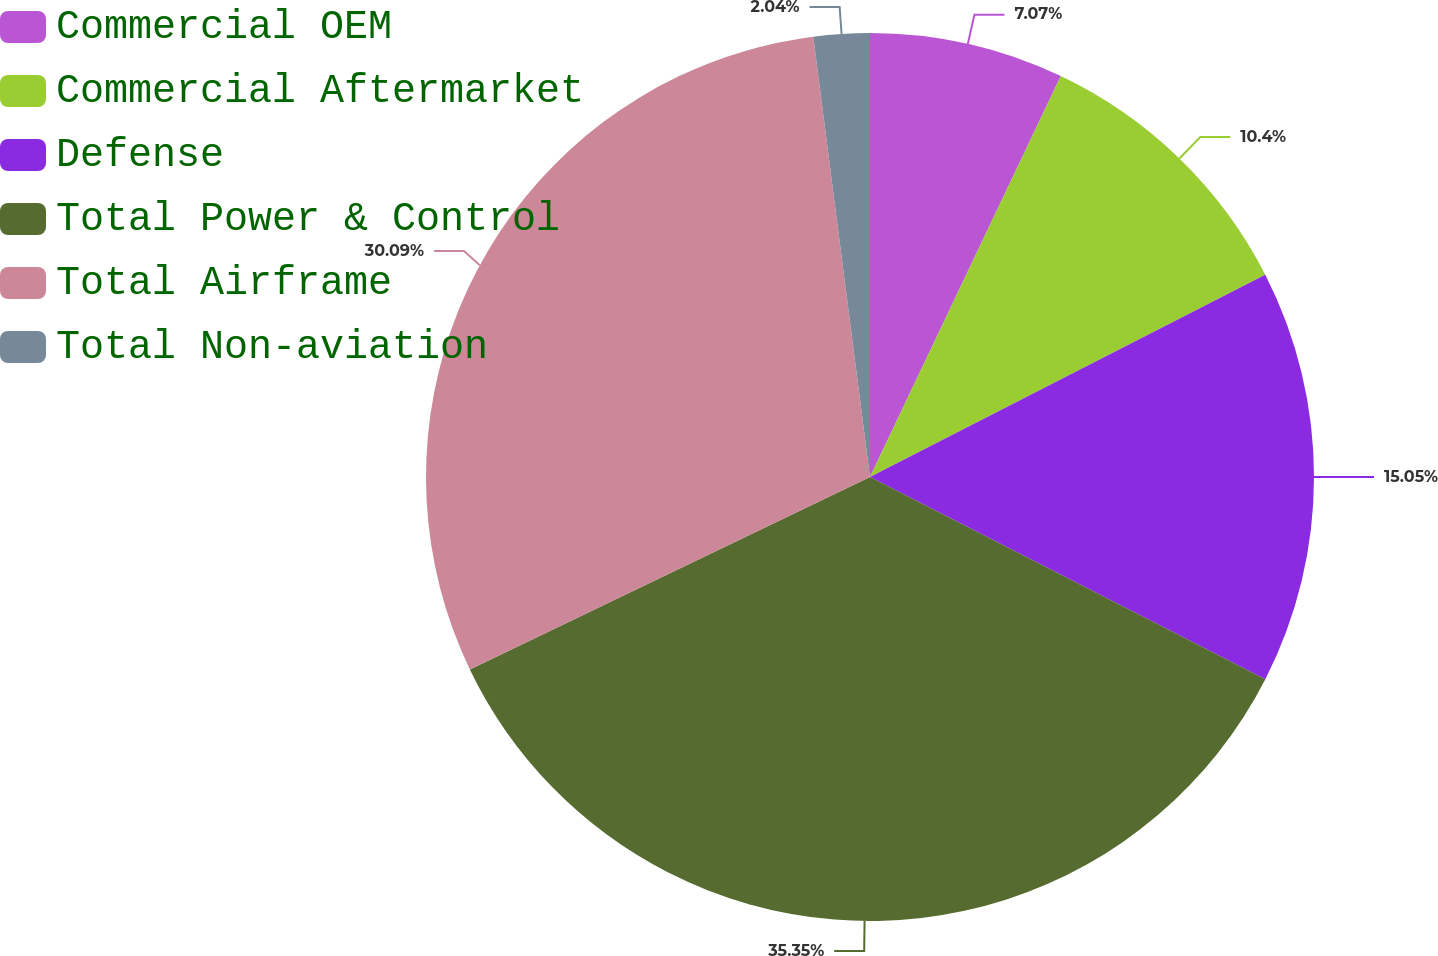<chart> <loc_0><loc_0><loc_500><loc_500><pie_chart><fcel>Commercial OEM<fcel>Commercial Aftermarket<fcel>Defense<fcel>Total Power & Control<fcel>Total Airframe<fcel>Total Non-aviation<nl><fcel>7.07%<fcel>10.4%<fcel>15.05%<fcel>35.34%<fcel>30.09%<fcel>2.04%<nl></chart> 